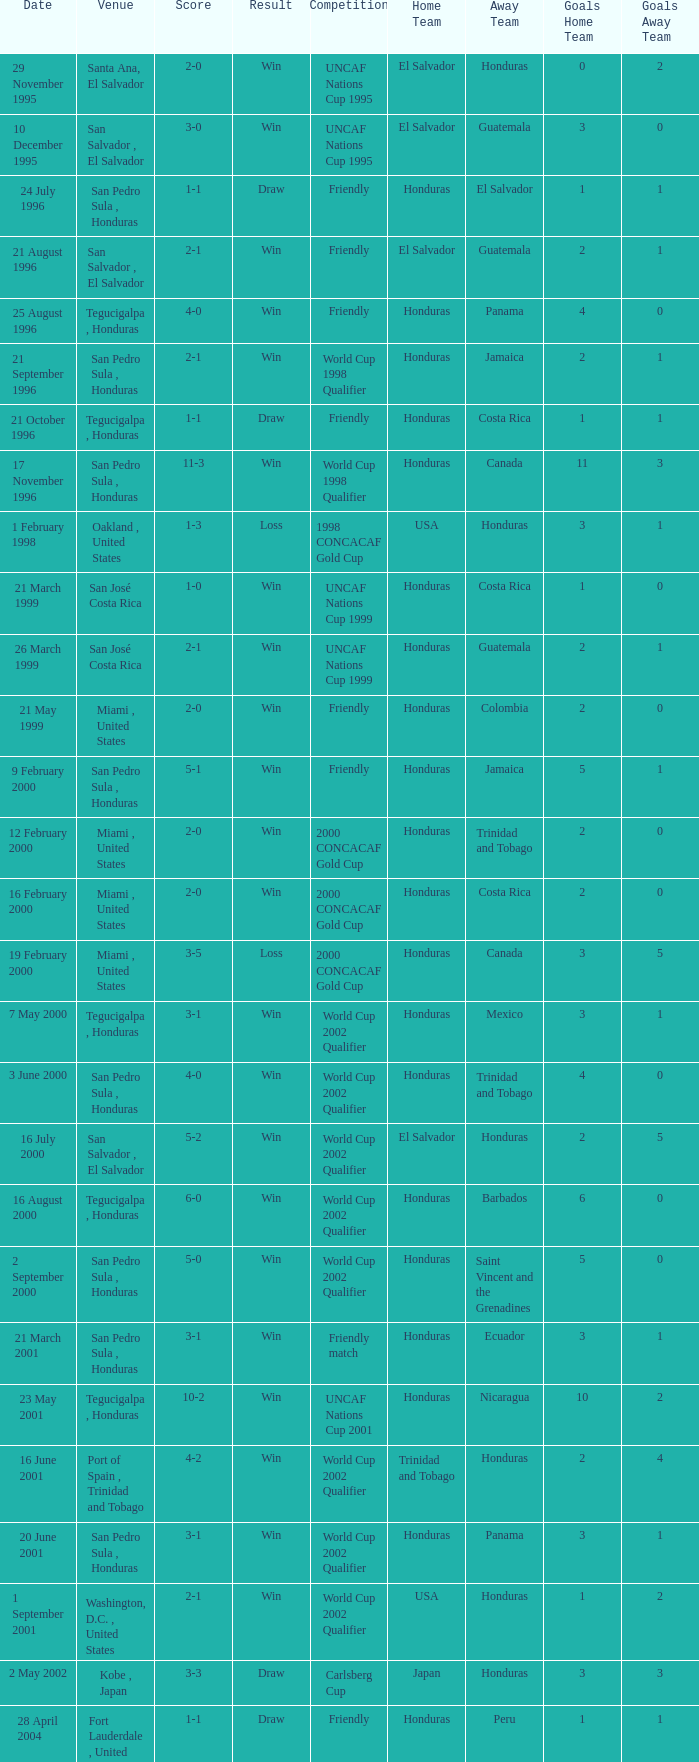Name the score for 7 may 2000 3-1. 